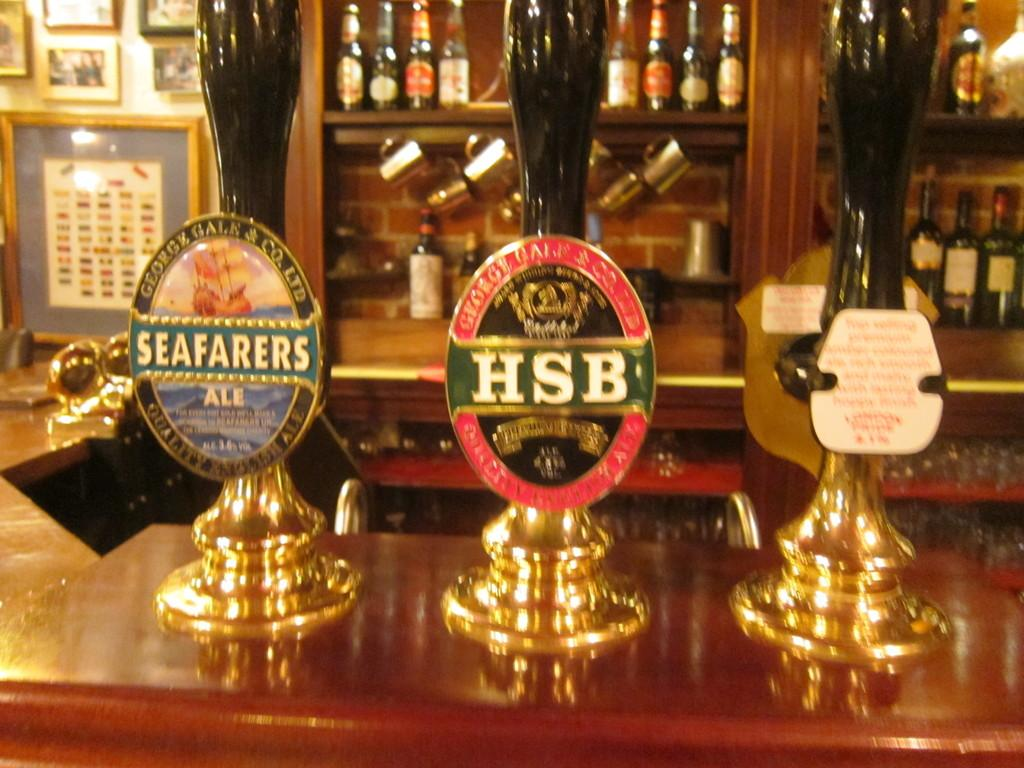<image>
Summarize the visual content of the image. A trio of bar taps include beers such as HSB and Seafarers Ale. 